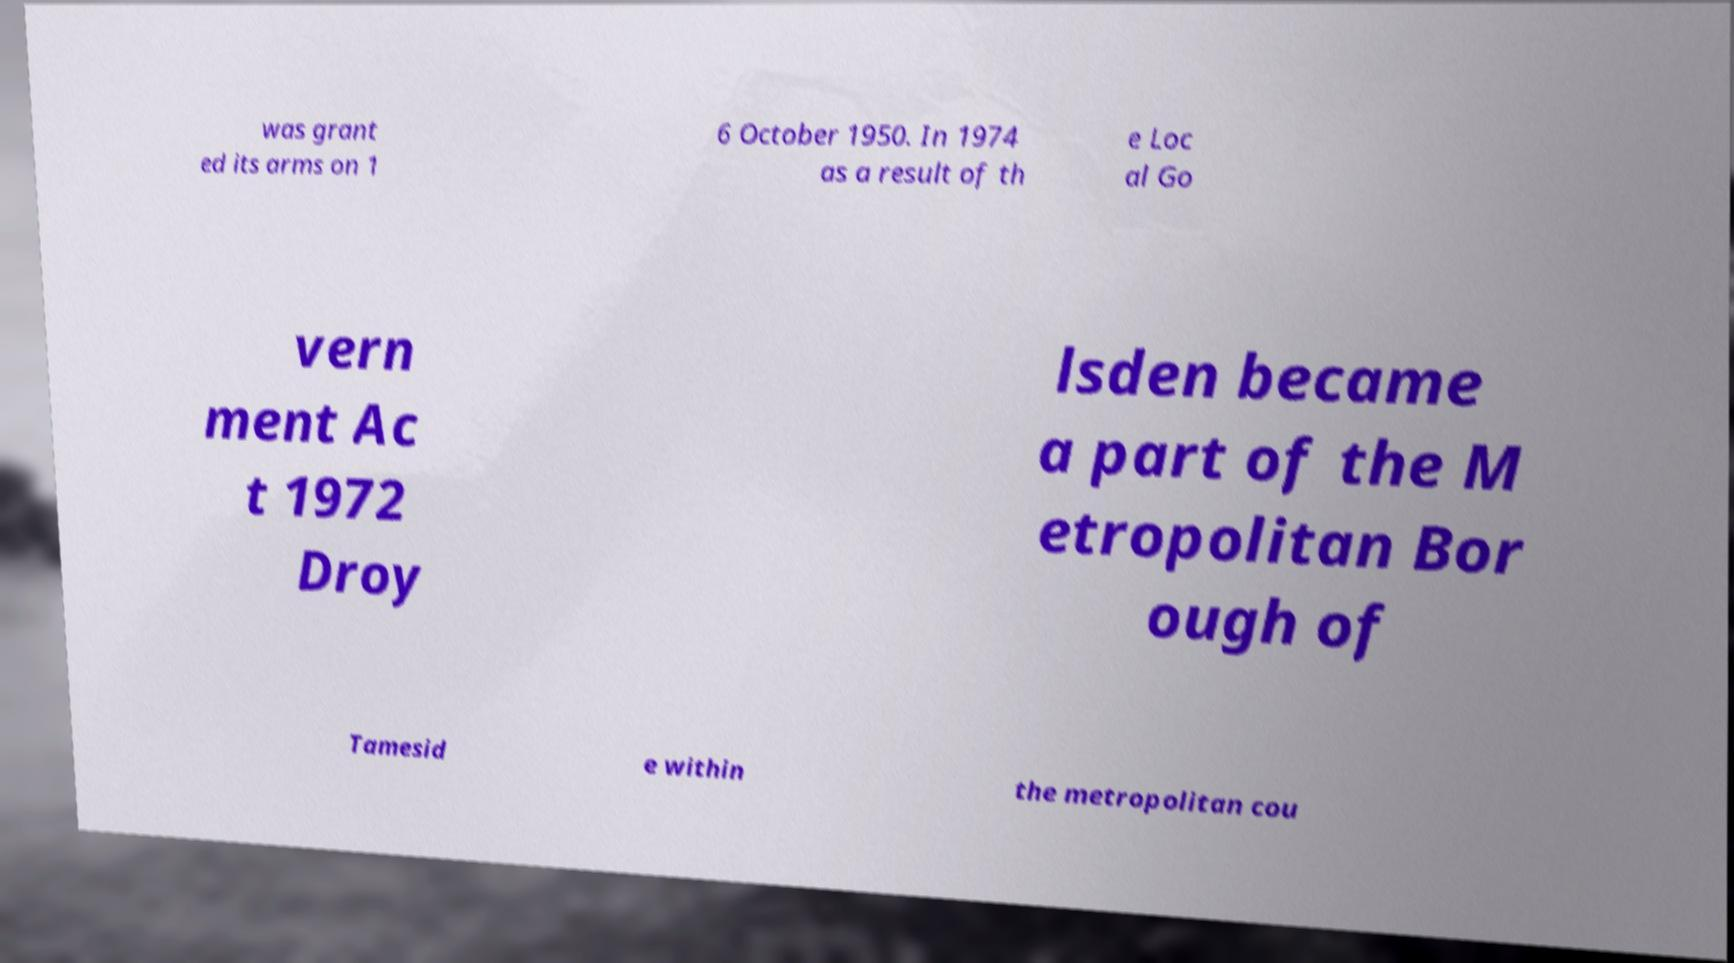What messages or text are displayed in this image? I need them in a readable, typed format. was grant ed its arms on 1 6 October 1950. In 1974 as a result of th e Loc al Go vern ment Ac t 1972 Droy lsden became a part of the M etropolitan Bor ough of Tamesid e within the metropolitan cou 